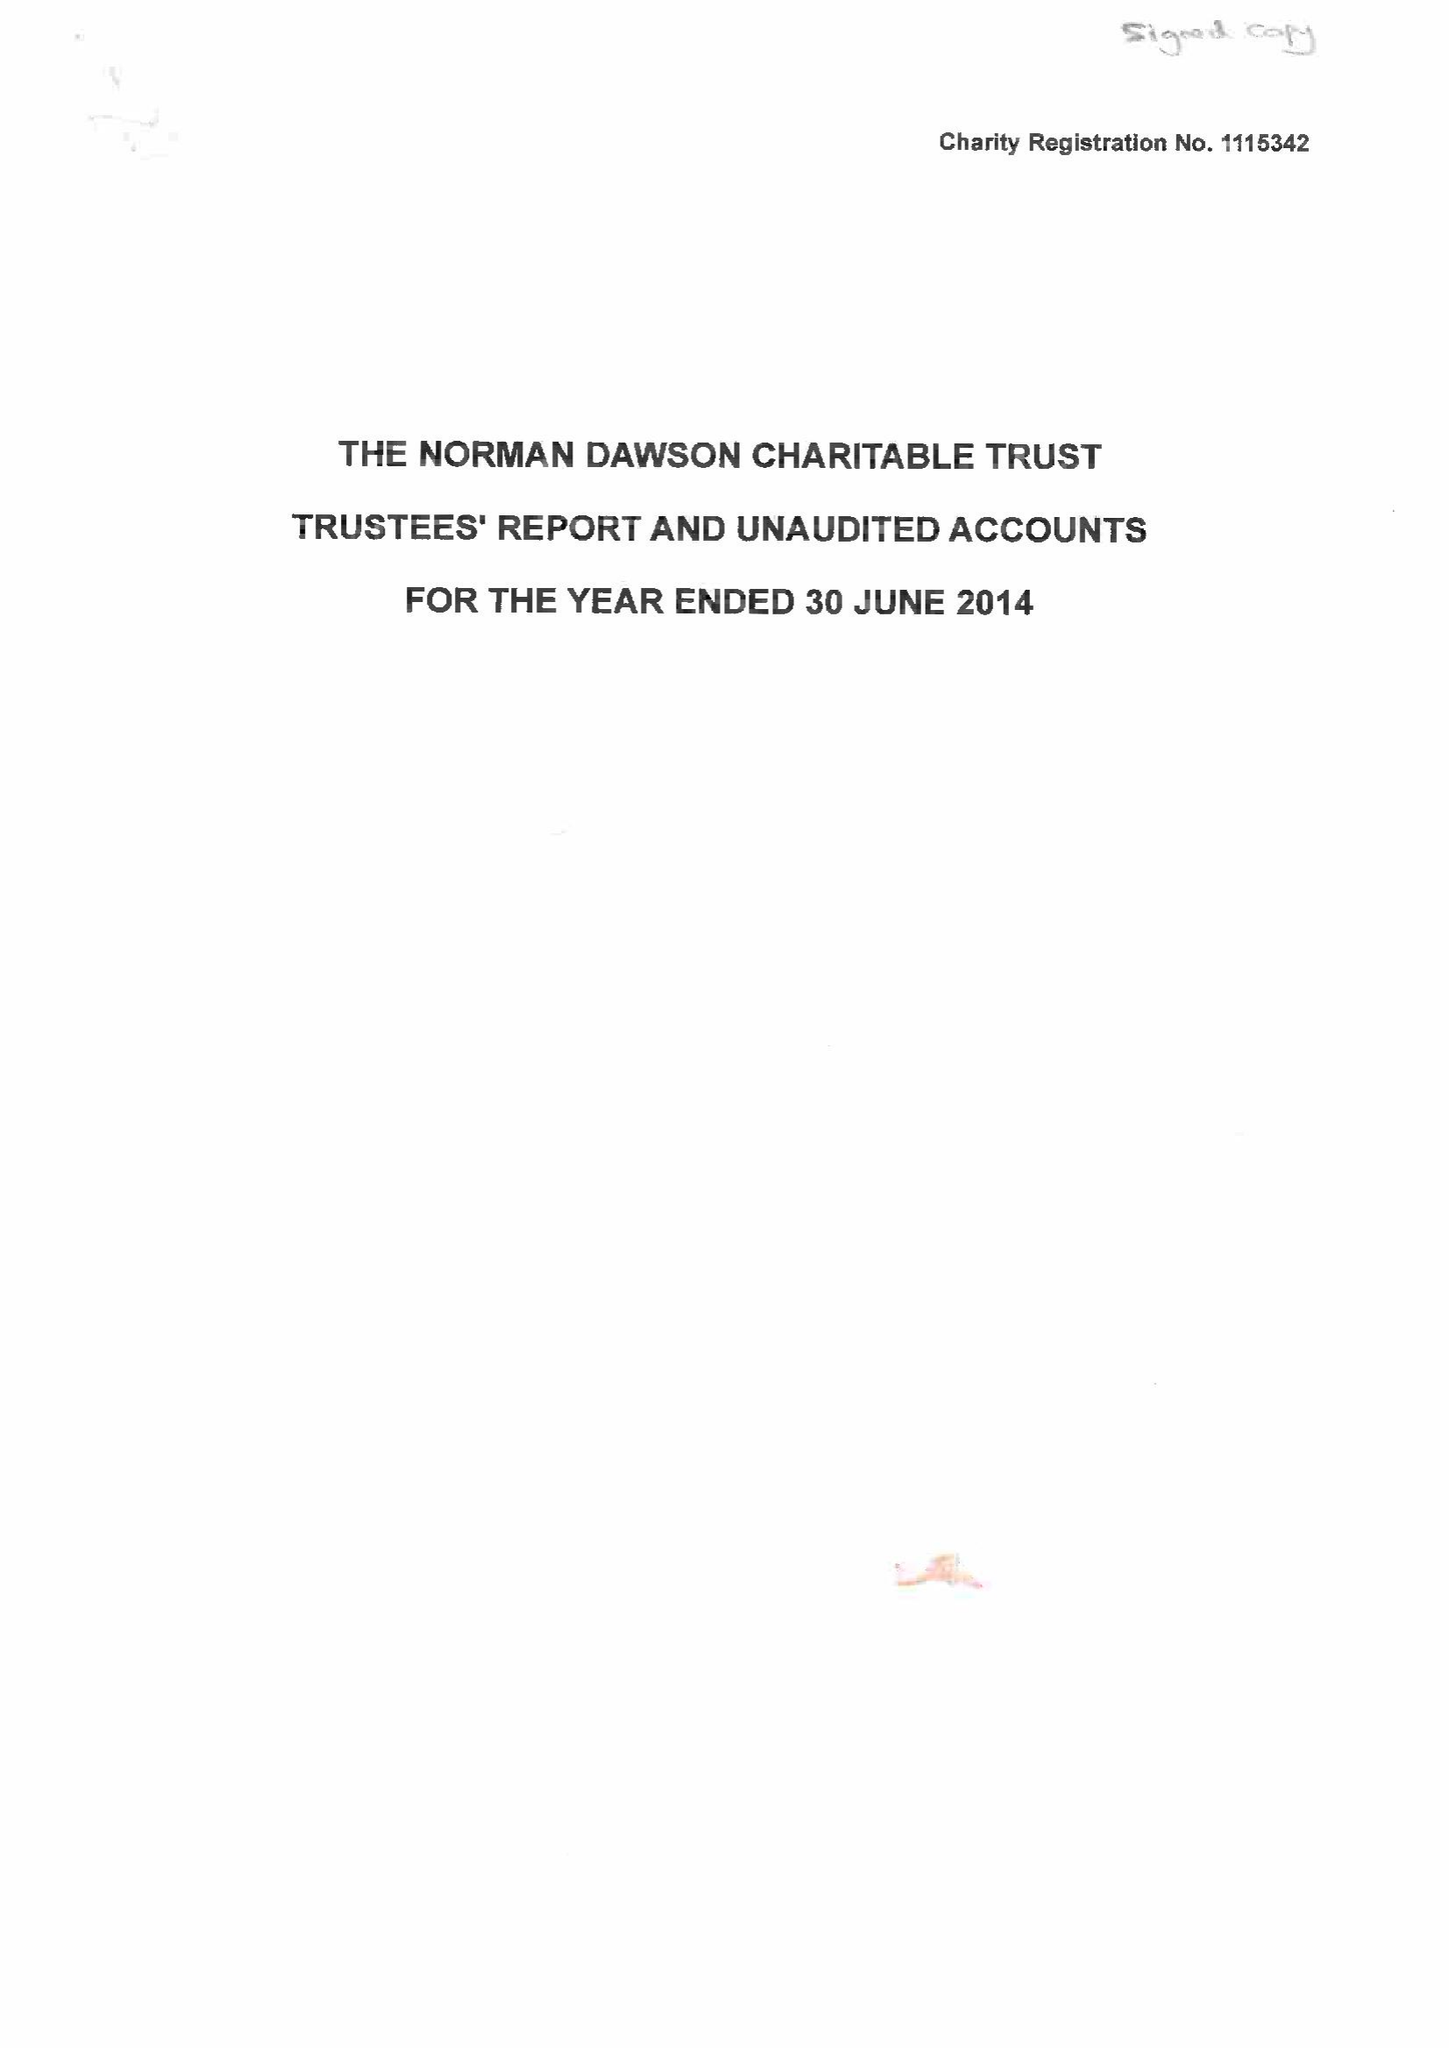What is the value for the spending_annually_in_british_pounds?
Answer the question using a single word or phrase. 33151.00 